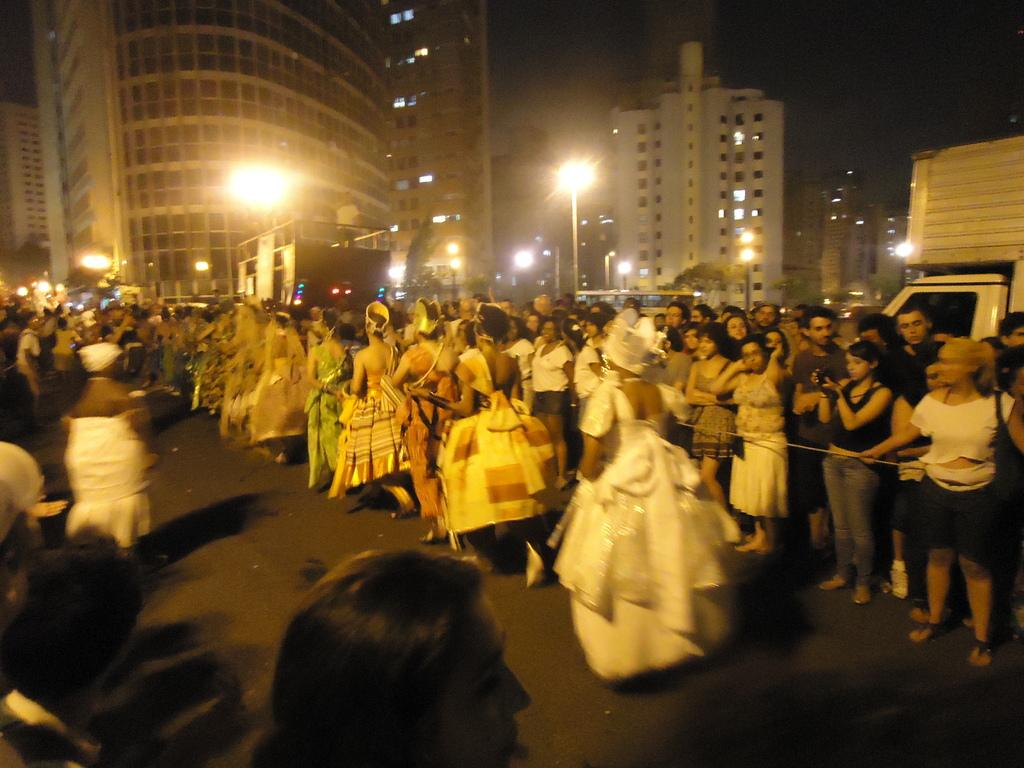Who or what is present in the image? There are people in the image. What structures can be seen in the image? There are light poles and buildings in the image. What type of vegetation is visible in the image? There are trees in the image. What is happening on the road in the image? There are vehicles on the road in the image. What can be seen in the background of the image? There are buildings and the sky visible in the background of the image. Can you tell me how many credits are being exchanged between the people in the image? There is no mention of credits or any financial transaction in the image; it features people, light poles, trees, vehicles, buildings, and the sky. What type of ball is being used by the people in the image? There is no ball present in the image; it features people, light poles, trees, vehicles, buildings, and the sky. 